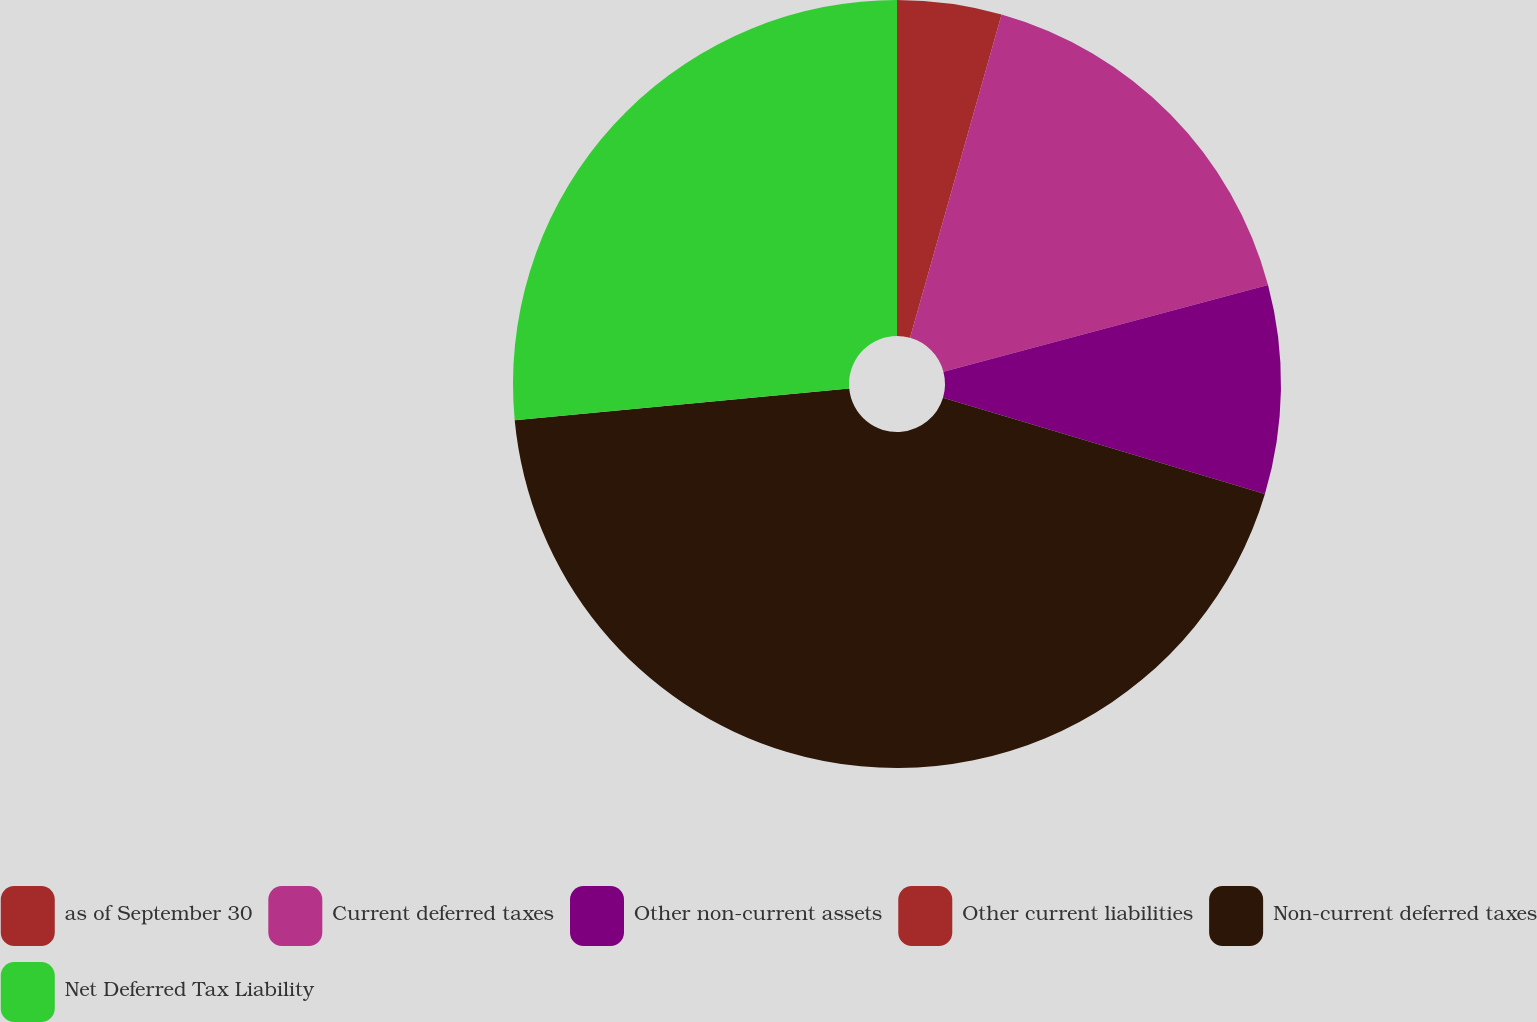<chart> <loc_0><loc_0><loc_500><loc_500><pie_chart><fcel>as of September 30<fcel>Current deferred taxes<fcel>Other non-current assets<fcel>Other current liabilities<fcel>Non-current deferred taxes<fcel>Net Deferred Tax Liability<nl><fcel>4.39%<fcel>16.46%<fcel>8.77%<fcel>0.0%<fcel>43.87%<fcel>26.5%<nl></chart> 